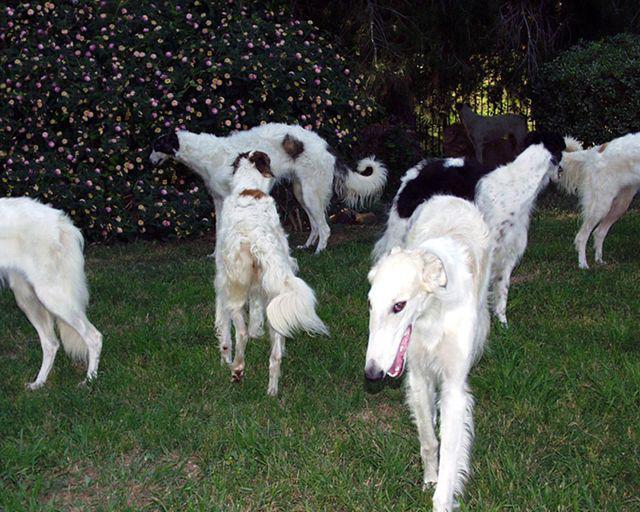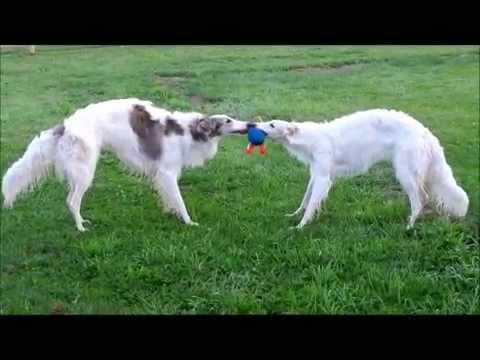The first image is the image on the left, the second image is the image on the right. Given the left and right images, does the statement "An image shows hounds standing on grass with a toy in the scene." hold true? Answer yes or no. Yes. 